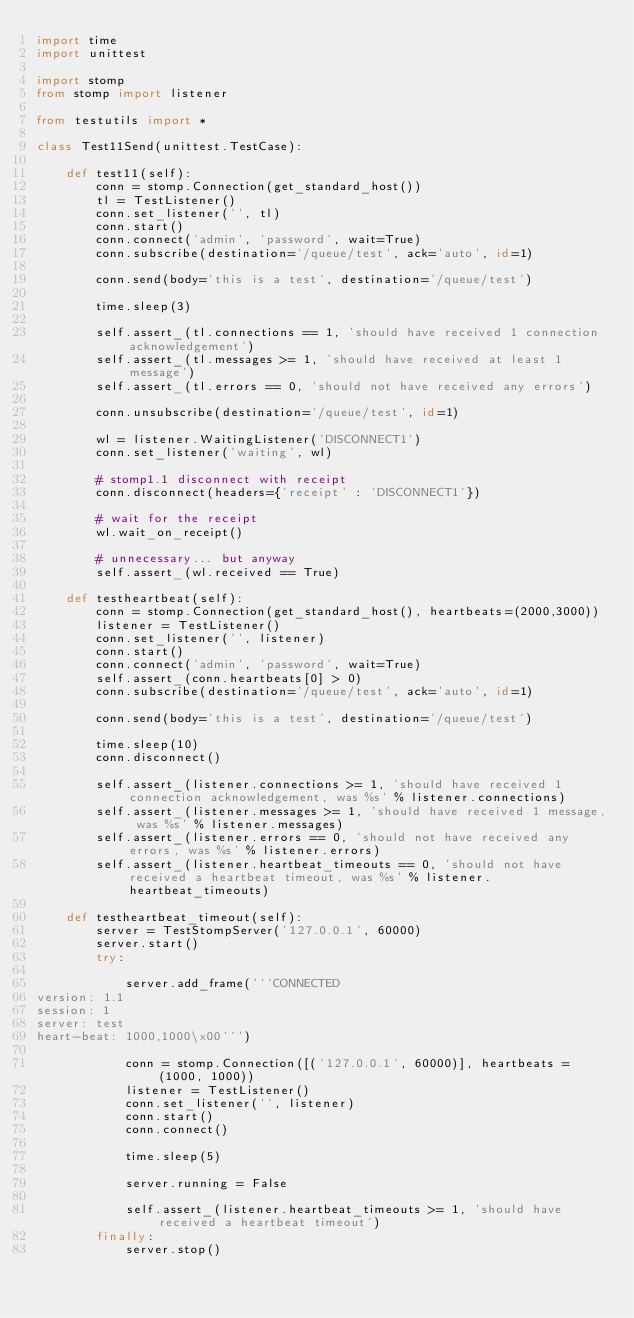<code> <loc_0><loc_0><loc_500><loc_500><_Python_>import time
import unittest

import stomp
from stomp import listener

from testutils import *

class Test11Send(unittest.TestCase):

    def test11(self):
        conn = stomp.Connection(get_standard_host())
        tl = TestListener()
        conn.set_listener('', tl)
        conn.start()
        conn.connect('admin', 'password', wait=True)
        conn.subscribe(destination='/queue/test', ack='auto', id=1)

        conn.send(body='this is a test', destination='/queue/test')

        time.sleep(3)

        self.assert_(tl.connections == 1, 'should have received 1 connection acknowledgement')
        self.assert_(tl.messages >= 1, 'should have received at least 1 message')
        self.assert_(tl.errors == 0, 'should not have received any errors')
        
        conn.unsubscribe(destination='/queue/test', id=1)
        
        wl = listener.WaitingListener('DISCONNECT1')
        conn.set_listener('waiting', wl)
        
        # stomp1.1 disconnect with receipt
        conn.disconnect(headers={'receipt' : 'DISCONNECT1'})
        
        # wait for the receipt
        wl.wait_on_receipt()
        
        # unnecessary... but anyway
        self.assert_(wl.received == True)
        
    def testheartbeat(self):
        conn = stomp.Connection(get_standard_host(), heartbeats=(2000,3000))
        listener = TestListener()
        conn.set_listener('', listener)
        conn.start()
        conn.connect('admin', 'password', wait=True)
        self.assert_(conn.heartbeats[0] > 0)
        conn.subscribe(destination='/queue/test', ack='auto', id=1)

        conn.send(body='this is a test', destination='/queue/test')

        time.sleep(10)
        conn.disconnect()

        self.assert_(listener.connections >= 1, 'should have received 1 connection acknowledgement, was %s' % listener.connections)
        self.assert_(listener.messages >= 1, 'should have received 1 message, was %s' % listener.messages)
        self.assert_(listener.errors == 0, 'should not have received any errors, was %s' % listener.errors)
        self.assert_(listener.heartbeat_timeouts == 0, 'should not have received a heartbeat timeout, was %s' % listener.heartbeat_timeouts)

    def testheartbeat_timeout(self):
        server = TestStompServer('127.0.0.1', 60000)
        server.start()
        try:

            server.add_frame('''CONNECTED
version: 1.1
session: 1
server: test
heart-beat: 1000,1000\x00''')

            conn = stomp.Connection([('127.0.0.1', 60000)], heartbeats = (1000, 1000))
            listener = TestListener()
            conn.set_listener('', listener)
            conn.start()
            conn.connect()

            time.sleep(5)

            server.running = False

            self.assert_(listener.heartbeat_timeouts >= 1, 'should have received a heartbeat timeout')
        finally:
            server.stop()
</code> 